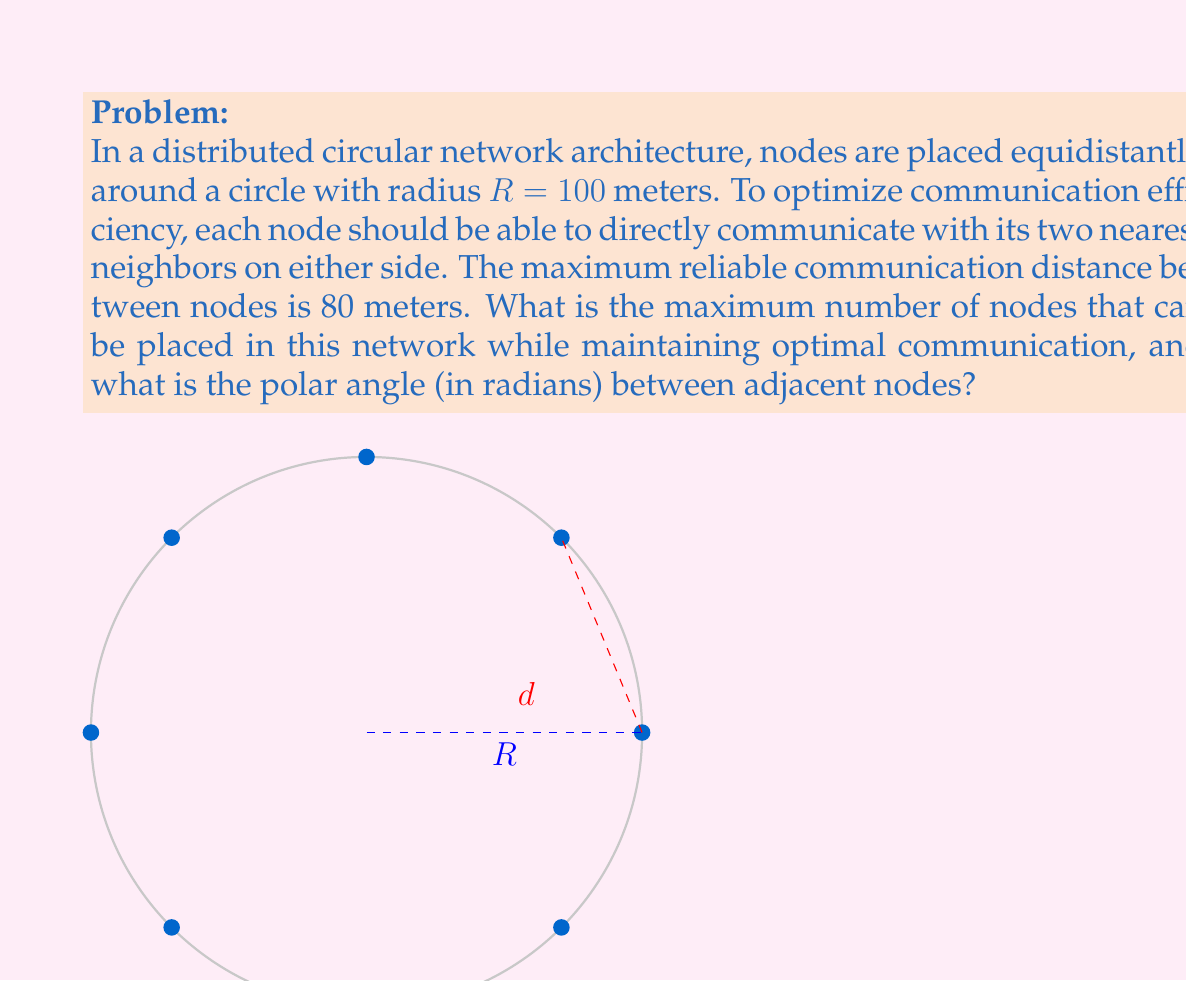Can you answer this question? Let's approach this step-by-step:

1) In a circular arrangement, the chord length $d$ between two adjacent nodes is related to the central angle $\theta$ (in radians) by the formula:

   $$d = 2R \sin(\frac{\theta}{2})$$

2) We know that the maximum communication distance is 80 meters, so $d \leq 80$. We can use this to find the minimum angle:

   $$80 = 2 \cdot 100 \sin(\frac{\theta}{2})$$
   $$0.4 = \sin(\frac{\theta}{2})$$
   $$\frac{\theta}{2} = \arcsin(0.4)$$
   $$\theta = 2 \arcsin(0.4) \approx 0.8107 \text{ radians}$$

3) The total angle around the circle is $2\pi$ radians. To find the maximum number of nodes, we divide $2\pi$ by the minimum angle between nodes:

   $$n = \frac{2\pi}{\theta} = \frac{2\pi}{2 \arcsin(0.4)} \approx 7.7516$$

4) Since we can only have a whole number of nodes, we round down to 7 nodes.

5) Now that we know the actual number of nodes, we can calculate the exact angle between adjacent nodes:

   $$\theta_{\text{actual}} = \frac{2\pi}{7} \approx 0.8976 \text{ radians}$$

This arrangement ensures that each node can communicate with its two nearest neighbors on either side, as the distance between adjacent nodes is:

$$d_{\text{actual}} = 2R \sin(\frac{\theta_{\text{actual}}}{2}) = 2 \cdot 100 \sin(\frac{\pi}{7}) \approx 86.78 \text{ meters}$$

Which is less than the maximum communication distance of 80 meters.
Answer: 7 nodes; $\frac{2\pi}{7}$ radians between adjacent nodes 